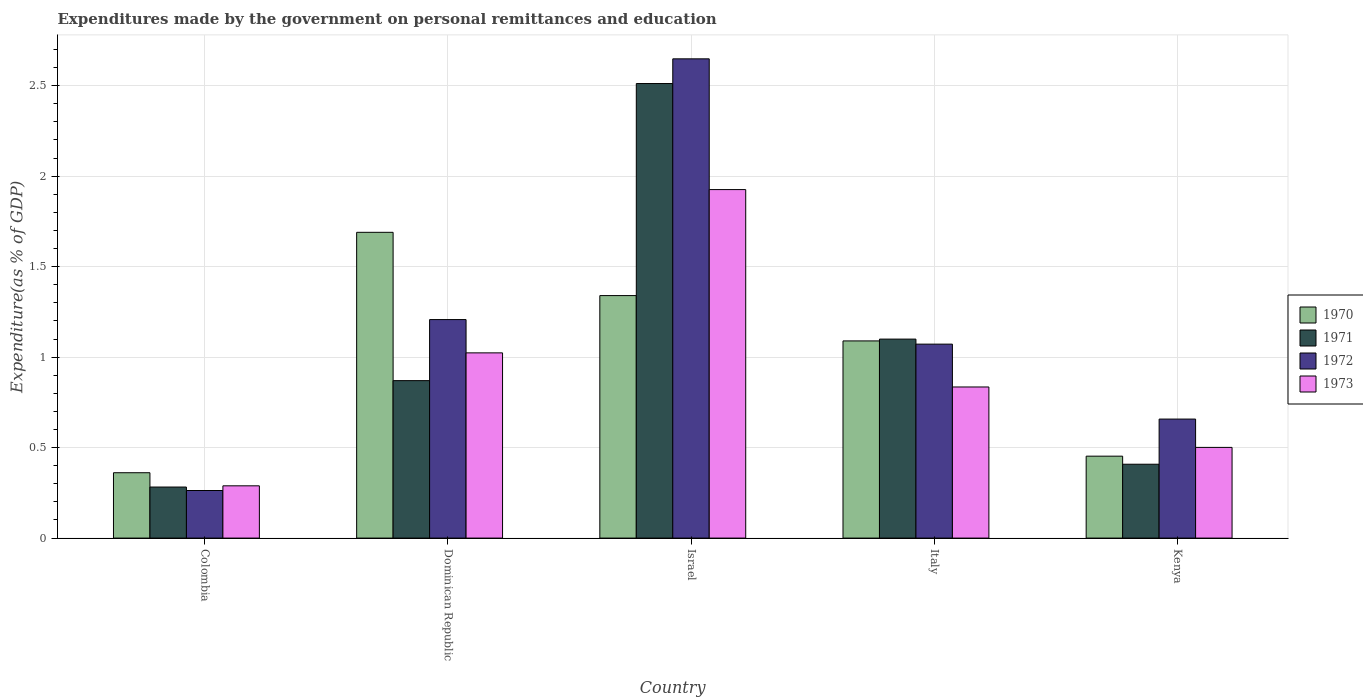Are the number of bars per tick equal to the number of legend labels?
Your answer should be compact. Yes. Are the number of bars on each tick of the X-axis equal?
Provide a succinct answer. Yes. How many bars are there on the 2nd tick from the left?
Offer a very short reply. 4. How many bars are there on the 4th tick from the right?
Provide a succinct answer. 4. What is the expenditures made by the government on personal remittances and education in 1972 in Dominican Republic?
Ensure brevity in your answer.  1.21. Across all countries, what is the maximum expenditures made by the government on personal remittances and education in 1970?
Offer a terse response. 1.69. Across all countries, what is the minimum expenditures made by the government on personal remittances and education in 1971?
Your answer should be compact. 0.28. In which country was the expenditures made by the government on personal remittances and education in 1972 maximum?
Offer a terse response. Israel. In which country was the expenditures made by the government on personal remittances and education in 1970 minimum?
Provide a succinct answer. Colombia. What is the total expenditures made by the government on personal remittances and education in 1971 in the graph?
Give a very brief answer. 5.17. What is the difference between the expenditures made by the government on personal remittances and education in 1972 in Colombia and that in Italy?
Offer a terse response. -0.81. What is the difference between the expenditures made by the government on personal remittances and education in 1970 in Dominican Republic and the expenditures made by the government on personal remittances and education in 1971 in Israel?
Keep it short and to the point. -0.82. What is the average expenditures made by the government on personal remittances and education in 1972 per country?
Your response must be concise. 1.17. What is the difference between the expenditures made by the government on personal remittances and education of/in 1970 and expenditures made by the government on personal remittances and education of/in 1973 in Kenya?
Your answer should be compact. -0.05. In how many countries, is the expenditures made by the government on personal remittances and education in 1970 greater than 1.4 %?
Your response must be concise. 1. What is the ratio of the expenditures made by the government on personal remittances and education in 1973 in Dominican Republic to that in Israel?
Offer a terse response. 0.53. Is the expenditures made by the government on personal remittances and education in 1971 in Dominican Republic less than that in Kenya?
Your answer should be compact. No. What is the difference between the highest and the second highest expenditures made by the government on personal remittances and education in 1971?
Ensure brevity in your answer.  -0.23. What is the difference between the highest and the lowest expenditures made by the government on personal remittances and education in 1973?
Offer a terse response. 1.64. What does the 3rd bar from the left in Colombia represents?
Offer a very short reply. 1972. What does the 2nd bar from the right in Israel represents?
Your response must be concise. 1972. Is it the case that in every country, the sum of the expenditures made by the government on personal remittances and education in 1972 and expenditures made by the government on personal remittances and education in 1970 is greater than the expenditures made by the government on personal remittances and education in 1971?
Provide a succinct answer. Yes. Does the graph contain any zero values?
Provide a short and direct response. No. How many legend labels are there?
Offer a terse response. 4. What is the title of the graph?
Make the answer very short. Expenditures made by the government on personal remittances and education. Does "1963" appear as one of the legend labels in the graph?
Your answer should be compact. No. What is the label or title of the Y-axis?
Your response must be concise. Expenditure(as % of GDP). What is the Expenditure(as % of GDP) of 1970 in Colombia?
Ensure brevity in your answer.  0.36. What is the Expenditure(as % of GDP) of 1971 in Colombia?
Keep it short and to the point. 0.28. What is the Expenditure(as % of GDP) of 1972 in Colombia?
Your answer should be compact. 0.26. What is the Expenditure(as % of GDP) in 1973 in Colombia?
Keep it short and to the point. 0.29. What is the Expenditure(as % of GDP) in 1970 in Dominican Republic?
Offer a very short reply. 1.69. What is the Expenditure(as % of GDP) of 1971 in Dominican Republic?
Provide a short and direct response. 0.87. What is the Expenditure(as % of GDP) of 1972 in Dominican Republic?
Provide a short and direct response. 1.21. What is the Expenditure(as % of GDP) in 1973 in Dominican Republic?
Keep it short and to the point. 1.02. What is the Expenditure(as % of GDP) in 1970 in Israel?
Your response must be concise. 1.34. What is the Expenditure(as % of GDP) of 1971 in Israel?
Ensure brevity in your answer.  2.51. What is the Expenditure(as % of GDP) of 1972 in Israel?
Ensure brevity in your answer.  2.65. What is the Expenditure(as % of GDP) of 1973 in Israel?
Offer a terse response. 1.93. What is the Expenditure(as % of GDP) in 1970 in Italy?
Your answer should be compact. 1.09. What is the Expenditure(as % of GDP) in 1971 in Italy?
Offer a very short reply. 1.1. What is the Expenditure(as % of GDP) of 1972 in Italy?
Your answer should be compact. 1.07. What is the Expenditure(as % of GDP) in 1973 in Italy?
Your answer should be compact. 0.84. What is the Expenditure(as % of GDP) in 1970 in Kenya?
Make the answer very short. 0.45. What is the Expenditure(as % of GDP) of 1971 in Kenya?
Ensure brevity in your answer.  0.41. What is the Expenditure(as % of GDP) of 1972 in Kenya?
Offer a very short reply. 0.66. What is the Expenditure(as % of GDP) in 1973 in Kenya?
Ensure brevity in your answer.  0.5. Across all countries, what is the maximum Expenditure(as % of GDP) in 1970?
Provide a succinct answer. 1.69. Across all countries, what is the maximum Expenditure(as % of GDP) of 1971?
Provide a succinct answer. 2.51. Across all countries, what is the maximum Expenditure(as % of GDP) of 1972?
Your answer should be compact. 2.65. Across all countries, what is the maximum Expenditure(as % of GDP) in 1973?
Your answer should be very brief. 1.93. Across all countries, what is the minimum Expenditure(as % of GDP) of 1970?
Offer a terse response. 0.36. Across all countries, what is the minimum Expenditure(as % of GDP) in 1971?
Your answer should be compact. 0.28. Across all countries, what is the minimum Expenditure(as % of GDP) in 1972?
Give a very brief answer. 0.26. Across all countries, what is the minimum Expenditure(as % of GDP) of 1973?
Give a very brief answer. 0.29. What is the total Expenditure(as % of GDP) of 1970 in the graph?
Provide a succinct answer. 4.93. What is the total Expenditure(as % of GDP) in 1971 in the graph?
Your response must be concise. 5.17. What is the total Expenditure(as % of GDP) of 1972 in the graph?
Your answer should be very brief. 5.85. What is the total Expenditure(as % of GDP) of 1973 in the graph?
Give a very brief answer. 4.57. What is the difference between the Expenditure(as % of GDP) of 1970 in Colombia and that in Dominican Republic?
Your response must be concise. -1.33. What is the difference between the Expenditure(as % of GDP) in 1971 in Colombia and that in Dominican Republic?
Offer a terse response. -0.59. What is the difference between the Expenditure(as % of GDP) of 1972 in Colombia and that in Dominican Republic?
Offer a terse response. -0.94. What is the difference between the Expenditure(as % of GDP) of 1973 in Colombia and that in Dominican Republic?
Keep it short and to the point. -0.73. What is the difference between the Expenditure(as % of GDP) in 1970 in Colombia and that in Israel?
Provide a succinct answer. -0.98. What is the difference between the Expenditure(as % of GDP) in 1971 in Colombia and that in Israel?
Offer a very short reply. -2.23. What is the difference between the Expenditure(as % of GDP) of 1972 in Colombia and that in Israel?
Ensure brevity in your answer.  -2.39. What is the difference between the Expenditure(as % of GDP) in 1973 in Colombia and that in Israel?
Your response must be concise. -1.64. What is the difference between the Expenditure(as % of GDP) in 1970 in Colombia and that in Italy?
Give a very brief answer. -0.73. What is the difference between the Expenditure(as % of GDP) in 1971 in Colombia and that in Italy?
Offer a very short reply. -0.82. What is the difference between the Expenditure(as % of GDP) in 1972 in Colombia and that in Italy?
Offer a very short reply. -0.81. What is the difference between the Expenditure(as % of GDP) of 1973 in Colombia and that in Italy?
Offer a terse response. -0.55. What is the difference between the Expenditure(as % of GDP) of 1970 in Colombia and that in Kenya?
Your answer should be very brief. -0.09. What is the difference between the Expenditure(as % of GDP) in 1971 in Colombia and that in Kenya?
Give a very brief answer. -0.13. What is the difference between the Expenditure(as % of GDP) of 1972 in Colombia and that in Kenya?
Offer a terse response. -0.39. What is the difference between the Expenditure(as % of GDP) in 1973 in Colombia and that in Kenya?
Provide a succinct answer. -0.21. What is the difference between the Expenditure(as % of GDP) in 1970 in Dominican Republic and that in Israel?
Ensure brevity in your answer.  0.35. What is the difference between the Expenditure(as % of GDP) in 1971 in Dominican Republic and that in Israel?
Your answer should be compact. -1.64. What is the difference between the Expenditure(as % of GDP) in 1972 in Dominican Republic and that in Israel?
Keep it short and to the point. -1.44. What is the difference between the Expenditure(as % of GDP) in 1973 in Dominican Republic and that in Israel?
Keep it short and to the point. -0.9. What is the difference between the Expenditure(as % of GDP) in 1970 in Dominican Republic and that in Italy?
Keep it short and to the point. 0.6. What is the difference between the Expenditure(as % of GDP) in 1971 in Dominican Republic and that in Italy?
Offer a terse response. -0.23. What is the difference between the Expenditure(as % of GDP) of 1972 in Dominican Republic and that in Italy?
Provide a short and direct response. 0.14. What is the difference between the Expenditure(as % of GDP) in 1973 in Dominican Republic and that in Italy?
Provide a short and direct response. 0.19. What is the difference between the Expenditure(as % of GDP) in 1970 in Dominican Republic and that in Kenya?
Your answer should be very brief. 1.24. What is the difference between the Expenditure(as % of GDP) of 1971 in Dominican Republic and that in Kenya?
Your answer should be compact. 0.46. What is the difference between the Expenditure(as % of GDP) of 1972 in Dominican Republic and that in Kenya?
Keep it short and to the point. 0.55. What is the difference between the Expenditure(as % of GDP) of 1973 in Dominican Republic and that in Kenya?
Your response must be concise. 0.52. What is the difference between the Expenditure(as % of GDP) of 1970 in Israel and that in Italy?
Your answer should be compact. 0.25. What is the difference between the Expenditure(as % of GDP) in 1971 in Israel and that in Italy?
Provide a short and direct response. 1.41. What is the difference between the Expenditure(as % of GDP) of 1972 in Israel and that in Italy?
Give a very brief answer. 1.58. What is the difference between the Expenditure(as % of GDP) of 1970 in Israel and that in Kenya?
Provide a short and direct response. 0.89. What is the difference between the Expenditure(as % of GDP) of 1971 in Israel and that in Kenya?
Give a very brief answer. 2.1. What is the difference between the Expenditure(as % of GDP) in 1972 in Israel and that in Kenya?
Give a very brief answer. 1.99. What is the difference between the Expenditure(as % of GDP) of 1973 in Israel and that in Kenya?
Ensure brevity in your answer.  1.42. What is the difference between the Expenditure(as % of GDP) of 1970 in Italy and that in Kenya?
Your answer should be compact. 0.64. What is the difference between the Expenditure(as % of GDP) in 1971 in Italy and that in Kenya?
Provide a succinct answer. 0.69. What is the difference between the Expenditure(as % of GDP) of 1972 in Italy and that in Kenya?
Make the answer very short. 0.41. What is the difference between the Expenditure(as % of GDP) in 1973 in Italy and that in Kenya?
Offer a very short reply. 0.33. What is the difference between the Expenditure(as % of GDP) of 1970 in Colombia and the Expenditure(as % of GDP) of 1971 in Dominican Republic?
Offer a very short reply. -0.51. What is the difference between the Expenditure(as % of GDP) in 1970 in Colombia and the Expenditure(as % of GDP) in 1972 in Dominican Republic?
Keep it short and to the point. -0.85. What is the difference between the Expenditure(as % of GDP) of 1970 in Colombia and the Expenditure(as % of GDP) of 1973 in Dominican Republic?
Make the answer very short. -0.66. What is the difference between the Expenditure(as % of GDP) in 1971 in Colombia and the Expenditure(as % of GDP) in 1972 in Dominican Republic?
Your response must be concise. -0.93. What is the difference between the Expenditure(as % of GDP) of 1971 in Colombia and the Expenditure(as % of GDP) of 1973 in Dominican Republic?
Offer a terse response. -0.74. What is the difference between the Expenditure(as % of GDP) in 1972 in Colombia and the Expenditure(as % of GDP) in 1973 in Dominican Republic?
Make the answer very short. -0.76. What is the difference between the Expenditure(as % of GDP) in 1970 in Colombia and the Expenditure(as % of GDP) in 1971 in Israel?
Your answer should be compact. -2.15. What is the difference between the Expenditure(as % of GDP) in 1970 in Colombia and the Expenditure(as % of GDP) in 1972 in Israel?
Your answer should be compact. -2.29. What is the difference between the Expenditure(as % of GDP) in 1970 in Colombia and the Expenditure(as % of GDP) in 1973 in Israel?
Provide a succinct answer. -1.56. What is the difference between the Expenditure(as % of GDP) of 1971 in Colombia and the Expenditure(as % of GDP) of 1972 in Israel?
Keep it short and to the point. -2.37. What is the difference between the Expenditure(as % of GDP) of 1971 in Colombia and the Expenditure(as % of GDP) of 1973 in Israel?
Your answer should be compact. -1.64. What is the difference between the Expenditure(as % of GDP) of 1972 in Colombia and the Expenditure(as % of GDP) of 1973 in Israel?
Offer a terse response. -1.66. What is the difference between the Expenditure(as % of GDP) of 1970 in Colombia and the Expenditure(as % of GDP) of 1971 in Italy?
Your response must be concise. -0.74. What is the difference between the Expenditure(as % of GDP) of 1970 in Colombia and the Expenditure(as % of GDP) of 1972 in Italy?
Your answer should be very brief. -0.71. What is the difference between the Expenditure(as % of GDP) of 1970 in Colombia and the Expenditure(as % of GDP) of 1973 in Italy?
Make the answer very short. -0.47. What is the difference between the Expenditure(as % of GDP) of 1971 in Colombia and the Expenditure(as % of GDP) of 1972 in Italy?
Offer a terse response. -0.79. What is the difference between the Expenditure(as % of GDP) of 1971 in Colombia and the Expenditure(as % of GDP) of 1973 in Italy?
Provide a succinct answer. -0.55. What is the difference between the Expenditure(as % of GDP) in 1972 in Colombia and the Expenditure(as % of GDP) in 1973 in Italy?
Give a very brief answer. -0.57. What is the difference between the Expenditure(as % of GDP) of 1970 in Colombia and the Expenditure(as % of GDP) of 1971 in Kenya?
Your answer should be very brief. -0.05. What is the difference between the Expenditure(as % of GDP) of 1970 in Colombia and the Expenditure(as % of GDP) of 1972 in Kenya?
Give a very brief answer. -0.3. What is the difference between the Expenditure(as % of GDP) of 1970 in Colombia and the Expenditure(as % of GDP) of 1973 in Kenya?
Your response must be concise. -0.14. What is the difference between the Expenditure(as % of GDP) in 1971 in Colombia and the Expenditure(as % of GDP) in 1972 in Kenya?
Provide a succinct answer. -0.38. What is the difference between the Expenditure(as % of GDP) of 1971 in Colombia and the Expenditure(as % of GDP) of 1973 in Kenya?
Your answer should be very brief. -0.22. What is the difference between the Expenditure(as % of GDP) in 1972 in Colombia and the Expenditure(as % of GDP) in 1973 in Kenya?
Ensure brevity in your answer.  -0.24. What is the difference between the Expenditure(as % of GDP) in 1970 in Dominican Republic and the Expenditure(as % of GDP) in 1971 in Israel?
Your response must be concise. -0.82. What is the difference between the Expenditure(as % of GDP) of 1970 in Dominican Republic and the Expenditure(as % of GDP) of 1972 in Israel?
Give a very brief answer. -0.96. What is the difference between the Expenditure(as % of GDP) in 1970 in Dominican Republic and the Expenditure(as % of GDP) in 1973 in Israel?
Your answer should be compact. -0.24. What is the difference between the Expenditure(as % of GDP) in 1971 in Dominican Republic and the Expenditure(as % of GDP) in 1972 in Israel?
Give a very brief answer. -1.78. What is the difference between the Expenditure(as % of GDP) of 1971 in Dominican Republic and the Expenditure(as % of GDP) of 1973 in Israel?
Your response must be concise. -1.06. What is the difference between the Expenditure(as % of GDP) in 1972 in Dominican Republic and the Expenditure(as % of GDP) in 1973 in Israel?
Provide a short and direct response. -0.72. What is the difference between the Expenditure(as % of GDP) in 1970 in Dominican Republic and the Expenditure(as % of GDP) in 1971 in Italy?
Offer a very short reply. 0.59. What is the difference between the Expenditure(as % of GDP) of 1970 in Dominican Republic and the Expenditure(as % of GDP) of 1972 in Italy?
Give a very brief answer. 0.62. What is the difference between the Expenditure(as % of GDP) of 1970 in Dominican Republic and the Expenditure(as % of GDP) of 1973 in Italy?
Your answer should be very brief. 0.85. What is the difference between the Expenditure(as % of GDP) in 1971 in Dominican Republic and the Expenditure(as % of GDP) in 1972 in Italy?
Offer a terse response. -0.2. What is the difference between the Expenditure(as % of GDP) of 1971 in Dominican Republic and the Expenditure(as % of GDP) of 1973 in Italy?
Give a very brief answer. 0.04. What is the difference between the Expenditure(as % of GDP) in 1972 in Dominican Republic and the Expenditure(as % of GDP) in 1973 in Italy?
Offer a very short reply. 0.37. What is the difference between the Expenditure(as % of GDP) in 1970 in Dominican Republic and the Expenditure(as % of GDP) in 1971 in Kenya?
Offer a very short reply. 1.28. What is the difference between the Expenditure(as % of GDP) of 1970 in Dominican Republic and the Expenditure(as % of GDP) of 1972 in Kenya?
Your answer should be compact. 1.03. What is the difference between the Expenditure(as % of GDP) in 1970 in Dominican Republic and the Expenditure(as % of GDP) in 1973 in Kenya?
Ensure brevity in your answer.  1.19. What is the difference between the Expenditure(as % of GDP) in 1971 in Dominican Republic and the Expenditure(as % of GDP) in 1972 in Kenya?
Offer a terse response. 0.21. What is the difference between the Expenditure(as % of GDP) in 1971 in Dominican Republic and the Expenditure(as % of GDP) in 1973 in Kenya?
Make the answer very short. 0.37. What is the difference between the Expenditure(as % of GDP) of 1972 in Dominican Republic and the Expenditure(as % of GDP) of 1973 in Kenya?
Make the answer very short. 0.71. What is the difference between the Expenditure(as % of GDP) of 1970 in Israel and the Expenditure(as % of GDP) of 1971 in Italy?
Provide a succinct answer. 0.24. What is the difference between the Expenditure(as % of GDP) in 1970 in Israel and the Expenditure(as % of GDP) in 1972 in Italy?
Your response must be concise. 0.27. What is the difference between the Expenditure(as % of GDP) of 1970 in Israel and the Expenditure(as % of GDP) of 1973 in Italy?
Keep it short and to the point. 0.51. What is the difference between the Expenditure(as % of GDP) in 1971 in Israel and the Expenditure(as % of GDP) in 1972 in Italy?
Provide a short and direct response. 1.44. What is the difference between the Expenditure(as % of GDP) of 1971 in Israel and the Expenditure(as % of GDP) of 1973 in Italy?
Make the answer very short. 1.68. What is the difference between the Expenditure(as % of GDP) of 1972 in Israel and the Expenditure(as % of GDP) of 1973 in Italy?
Your answer should be compact. 1.81. What is the difference between the Expenditure(as % of GDP) in 1970 in Israel and the Expenditure(as % of GDP) in 1971 in Kenya?
Offer a very short reply. 0.93. What is the difference between the Expenditure(as % of GDP) of 1970 in Israel and the Expenditure(as % of GDP) of 1972 in Kenya?
Keep it short and to the point. 0.68. What is the difference between the Expenditure(as % of GDP) in 1970 in Israel and the Expenditure(as % of GDP) in 1973 in Kenya?
Your answer should be compact. 0.84. What is the difference between the Expenditure(as % of GDP) in 1971 in Israel and the Expenditure(as % of GDP) in 1972 in Kenya?
Your answer should be compact. 1.85. What is the difference between the Expenditure(as % of GDP) in 1971 in Israel and the Expenditure(as % of GDP) in 1973 in Kenya?
Your response must be concise. 2.01. What is the difference between the Expenditure(as % of GDP) of 1972 in Israel and the Expenditure(as % of GDP) of 1973 in Kenya?
Offer a very short reply. 2.15. What is the difference between the Expenditure(as % of GDP) in 1970 in Italy and the Expenditure(as % of GDP) in 1971 in Kenya?
Provide a succinct answer. 0.68. What is the difference between the Expenditure(as % of GDP) in 1970 in Italy and the Expenditure(as % of GDP) in 1972 in Kenya?
Your answer should be very brief. 0.43. What is the difference between the Expenditure(as % of GDP) of 1970 in Italy and the Expenditure(as % of GDP) of 1973 in Kenya?
Provide a succinct answer. 0.59. What is the difference between the Expenditure(as % of GDP) in 1971 in Italy and the Expenditure(as % of GDP) in 1972 in Kenya?
Your answer should be very brief. 0.44. What is the difference between the Expenditure(as % of GDP) in 1971 in Italy and the Expenditure(as % of GDP) in 1973 in Kenya?
Ensure brevity in your answer.  0.6. What is the difference between the Expenditure(as % of GDP) of 1972 in Italy and the Expenditure(as % of GDP) of 1973 in Kenya?
Your response must be concise. 0.57. What is the average Expenditure(as % of GDP) in 1970 per country?
Your response must be concise. 0.99. What is the average Expenditure(as % of GDP) in 1971 per country?
Make the answer very short. 1.03. What is the average Expenditure(as % of GDP) in 1972 per country?
Offer a very short reply. 1.17. What is the average Expenditure(as % of GDP) in 1973 per country?
Offer a very short reply. 0.91. What is the difference between the Expenditure(as % of GDP) of 1970 and Expenditure(as % of GDP) of 1971 in Colombia?
Provide a short and direct response. 0.08. What is the difference between the Expenditure(as % of GDP) of 1970 and Expenditure(as % of GDP) of 1972 in Colombia?
Provide a short and direct response. 0.1. What is the difference between the Expenditure(as % of GDP) of 1970 and Expenditure(as % of GDP) of 1973 in Colombia?
Make the answer very short. 0.07. What is the difference between the Expenditure(as % of GDP) in 1971 and Expenditure(as % of GDP) in 1972 in Colombia?
Give a very brief answer. 0.02. What is the difference between the Expenditure(as % of GDP) in 1971 and Expenditure(as % of GDP) in 1973 in Colombia?
Give a very brief answer. -0.01. What is the difference between the Expenditure(as % of GDP) in 1972 and Expenditure(as % of GDP) in 1973 in Colombia?
Ensure brevity in your answer.  -0.03. What is the difference between the Expenditure(as % of GDP) in 1970 and Expenditure(as % of GDP) in 1971 in Dominican Republic?
Your answer should be very brief. 0.82. What is the difference between the Expenditure(as % of GDP) of 1970 and Expenditure(as % of GDP) of 1972 in Dominican Republic?
Provide a short and direct response. 0.48. What is the difference between the Expenditure(as % of GDP) of 1970 and Expenditure(as % of GDP) of 1973 in Dominican Republic?
Provide a succinct answer. 0.67. What is the difference between the Expenditure(as % of GDP) in 1971 and Expenditure(as % of GDP) in 1972 in Dominican Republic?
Provide a succinct answer. -0.34. What is the difference between the Expenditure(as % of GDP) in 1971 and Expenditure(as % of GDP) in 1973 in Dominican Republic?
Provide a succinct answer. -0.15. What is the difference between the Expenditure(as % of GDP) of 1972 and Expenditure(as % of GDP) of 1973 in Dominican Republic?
Your response must be concise. 0.18. What is the difference between the Expenditure(as % of GDP) of 1970 and Expenditure(as % of GDP) of 1971 in Israel?
Provide a succinct answer. -1.17. What is the difference between the Expenditure(as % of GDP) in 1970 and Expenditure(as % of GDP) in 1972 in Israel?
Make the answer very short. -1.31. What is the difference between the Expenditure(as % of GDP) in 1970 and Expenditure(as % of GDP) in 1973 in Israel?
Provide a succinct answer. -0.59. What is the difference between the Expenditure(as % of GDP) in 1971 and Expenditure(as % of GDP) in 1972 in Israel?
Offer a very short reply. -0.14. What is the difference between the Expenditure(as % of GDP) in 1971 and Expenditure(as % of GDP) in 1973 in Israel?
Your answer should be very brief. 0.59. What is the difference between the Expenditure(as % of GDP) in 1972 and Expenditure(as % of GDP) in 1973 in Israel?
Give a very brief answer. 0.72. What is the difference between the Expenditure(as % of GDP) in 1970 and Expenditure(as % of GDP) in 1971 in Italy?
Ensure brevity in your answer.  -0.01. What is the difference between the Expenditure(as % of GDP) of 1970 and Expenditure(as % of GDP) of 1972 in Italy?
Offer a terse response. 0.02. What is the difference between the Expenditure(as % of GDP) of 1970 and Expenditure(as % of GDP) of 1973 in Italy?
Offer a very short reply. 0.25. What is the difference between the Expenditure(as % of GDP) of 1971 and Expenditure(as % of GDP) of 1972 in Italy?
Your response must be concise. 0.03. What is the difference between the Expenditure(as % of GDP) in 1971 and Expenditure(as % of GDP) in 1973 in Italy?
Ensure brevity in your answer.  0.26. What is the difference between the Expenditure(as % of GDP) of 1972 and Expenditure(as % of GDP) of 1973 in Italy?
Provide a short and direct response. 0.24. What is the difference between the Expenditure(as % of GDP) in 1970 and Expenditure(as % of GDP) in 1971 in Kenya?
Ensure brevity in your answer.  0.04. What is the difference between the Expenditure(as % of GDP) of 1970 and Expenditure(as % of GDP) of 1972 in Kenya?
Give a very brief answer. -0.2. What is the difference between the Expenditure(as % of GDP) in 1970 and Expenditure(as % of GDP) in 1973 in Kenya?
Your response must be concise. -0.05. What is the difference between the Expenditure(as % of GDP) in 1971 and Expenditure(as % of GDP) in 1972 in Kenya?
Give a very brief answer. -0.25. What is the difference between the Expenditure(as % of GDP) of 1971 and Expenditure(as % of GDP) of 1973 in Kenya?
Your answer should be compact. -0.09. What is the difference between the Expenditure(as % of GDP) in 1972 and Expenditure(as % of GDP) in 1973 in Kenya?
Make the answer very short. 0.16. What is the ratio of the Expenditure(as % of GDP) of 1970 in Colombia to that in Dominican Republic?
Ensure brevity in your answer.  0.21. What is the ratio of the Expenditure(as % of GDP) in 1971 in Colombia to that in Dominican Republic?
Give a very brief answer. 0.32. What is the ratio of the Expenditure(as % of GDP) in 1972 in Colombia to that in Dominican Republic?
Provide a short and direct response. 0.22. What is the ratio of the Expenditure(as % of GDP) in 1973 in Colombia to that in Dominican Republic?
Offer a terse response. 0.28. What is the ratio of the Expenditure(as % of GDP) of 1970 in Colombia to that in Israel?
Your answer should be very brief. 0.27. What is the ratio of the Expenditure(as % of GDP) in 1971 in Colombia to that in Israel?
Ensure brevity in your answer.  0.11. What is the ratio of the Expenditure(as % of GDP) in 1972 in Colombia to that in Israel?
Your answer should be compact. 0.1. What is the ratio of the Expenditure(as % of GDP) of 1970 in Colombia to that in Italy?
Keep it short and to the point. 0.33. What is the ratio of the Expenditure(as % of GDP) of 1971 in Colombia to that in Italy?
Keep it short and to the point. 0.26. What is the ratio of the Expenditure(as % of GDP) in 1972 in Colombia to that in Italy?
Your response must be concise. 0.25. What is the ratio of the Expenditure(as % of GDP) in 1973 in Colombia to that in Italy?
Offer a terse response. 0.35. What is the ratio of the Expenditure(as % of GDP) in 1970 in Colombia to that in Kenya?
Provide a short and direct response. 0.8. What is the ratio of the Expenditure(as % of GDP) in 1971 in Colombia to that in Kenya?
Offer a terse response. 0.69. What is the ratio of the Expenditure(as % of GDP) in 1972 in Colombia to that in Kenya?
Provide a succinct answer. 0.4. What is the ratio of the Expenditure(as % of GDP) in 1973 in Colombia to that in Kenya?
Give a very brief answer. 0.58. What is the ratio of the Expenditure(as % of GDP) of 1970 in Dominican Republic to that in Israel?
Keep it short and to the point. 1.26. What is the ratio of the Expenditure(as % of GDP) of 1971 in Dominican Republic to that in Israel?
Your answer should be very brief. 0.35. What is the ratio of the Expenditure(as % of GDP) in 1972 in Dominican Republic to that in Israel?
Make the answer very short. 0.46. What is the ratio of the Expenditure(as % of GDP) of 1973 in Dominican Republic to that in Israel?
Make the answer very short. 0.53. What is the ratio of the Expenditure(as % of GDP) in 1970 in Dominican Republic to that in Italy?
Ensure brevity in your answer.  1.55. What is the ratio of the Expenditure(as % of GDP) of 1971 in Dominican Republic to that in Italy?
Provide a succinct answer. 0.79. What is the ratio of the Expenditure(as % of GDP) of 1972 in Dominican Republic to that in Italy?
Give a very brief answer. 1.13. What is the ratio of the Expenditure(as % of GDP) in 1973 in Dominican Republic to that in Italy?
Ensure brevity in your answer.  1.23. What is the ratio of the Expenditure(as % of GDP) of 1970 in Dominican Republic to that in Kenya?
Ensure brevity in your answer.  3.73. What is the ratio of the Expenditure(as % of GDP) in 1971 in Dominican Republic to that in Kenya?
Your answer should be very brief. 2.13. What is the ratio of the Expenditure(as % of GDP) in 1972 in Dominican Republic to that in Kenya?
Give a very brief answer. 1.84. What is the ratio of the Expenditure(as % of GDP) of 1973 in Dominican Republic to that in Kenya?
Give a very brief answer. 2.04. What is the ratio of the Expenditure(as % of GDP) of 1970 in Israel to that in Italy?
Provide a succinct answer. 1.23. What is the ratio of the Expenditure(as % of GDP) in 1971 in Israel to that in Italy?
Give a very brief answer. 2.28. What is the ratio of the Expenditure(as % of GDP) in 1972 in Israel to that in Italy?
Your answer should be compact. 2.47. What is the ratio of the Expenditure(as % of GDP) in 1973 in Israel to that in Italy?
Make the answer very short. 2.31. What is the ratio of the Expenditure(as % of GDP) in 1970 in Israel to that in Kenya?
Make the answer very short. 2.96. What is the ratio of the Expenditure(as % of GDP) in 1971 in Israel to that in Kenya?
Provide a short and direct response. 6.15. What is the ratio of the Expenditure(as % of GDP) of 1972 in Israel to that in Kenya?
Provide a short and direct response. 4.03. What is the ratio of the Expenditure(as % of GDP) of 1973 in Israel to that in Kenya?
Offer a terse response. 3.84. What is the ratio of the Expenditure(as % of GDP) of 1970 in Italy to that in Kenya?
Provide a short and direct response. 2.41. What is the ratio of the Expenditure(as % of GDP) in 1971 in Italy to that in Kenya?
Offer a terse response. 2.69. What is the ratio of the Expenditure(as % of GDP) in 1972 in Italy to that in Kenya?
Your answer should be very brief. 1.63. What is the ratio of the Expenditure(as % of GDP) of 1973 in Italy to that in Kenya?
Your answer should be compact. 1.67. What is the difference between the highest and the second highest Expenditure(as % of GDP) of 1970?
Give a very brief answer. 0.35. What is the difference between the highest and the second highest Expenditure(as % of GDP) in 1971?
Give a very brief answer. 1.41. What is the difference between the highest and the second highest Expenditure(as % of GDP) in 1972?
Offer a terse response. 1.44. What is the difference between the highest and the second highest Expenditure(as % of GDP) of 1973?
Give a very brief answer. 0.9. What is the difference between the highest and the lowest Expenditure(as % of GDP) in 1970?
Provide a succinct answer. 1.33. What is the difference between the highest and the lowest Expenditure(as % of GDP) in 1971?
Provide a short and direct response. 2.23. What is the difference between the highest and the lowest Expenditure(as % of GDP) of 1972?
Your response must be concise. 2.39. What is the difference between the highest and the lowest Expenditure(as % of GDP) of 1973?
Give a very brief answer. 1.64. 